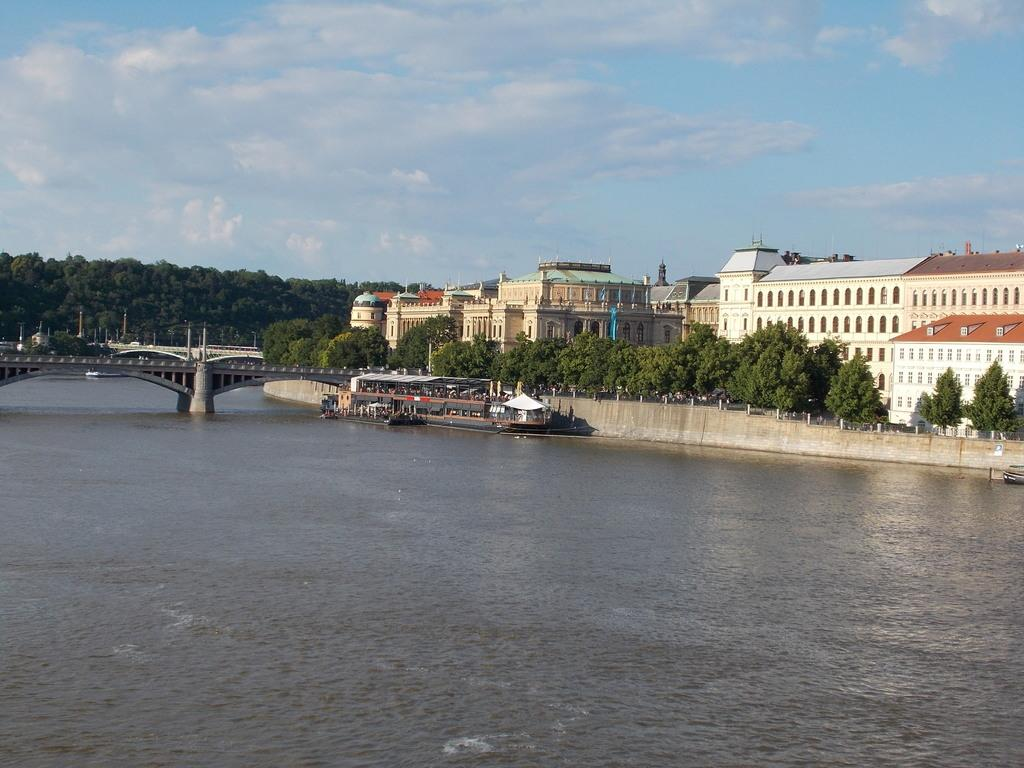What is the main subject of the image? The main subject of the image is a boat. What can you tell about the appearance of the boat? The boat is black and white in color. Where is the boat located in the image? The boat is on the water. What can be seen in the background of the image? In the background of the image, there is a bridge, trees, buildings, and the sky. How many rocks can be seen in the image? There are no rocks visible in the image; it features a black and white boat on the water with a background that includes a bridge, trees, buildings, and the sky. 